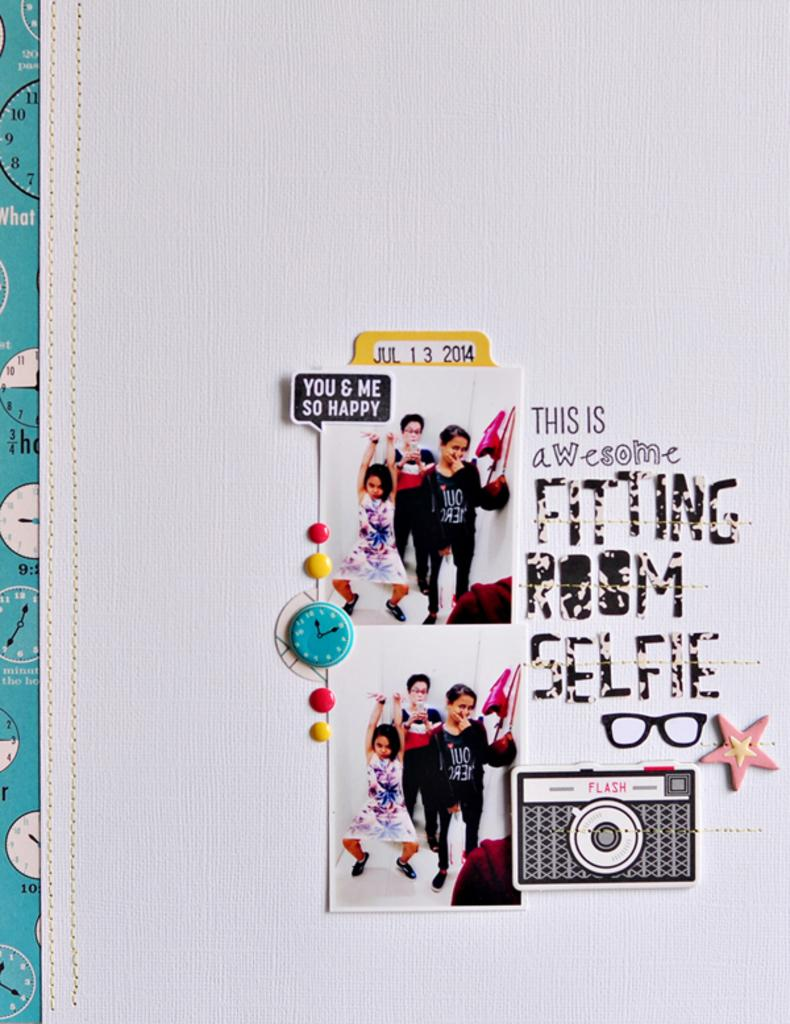<image>
Give a short and clear explanation of the subsequent image. A date of Jul 13 2014 is visible above "this is awesome." 